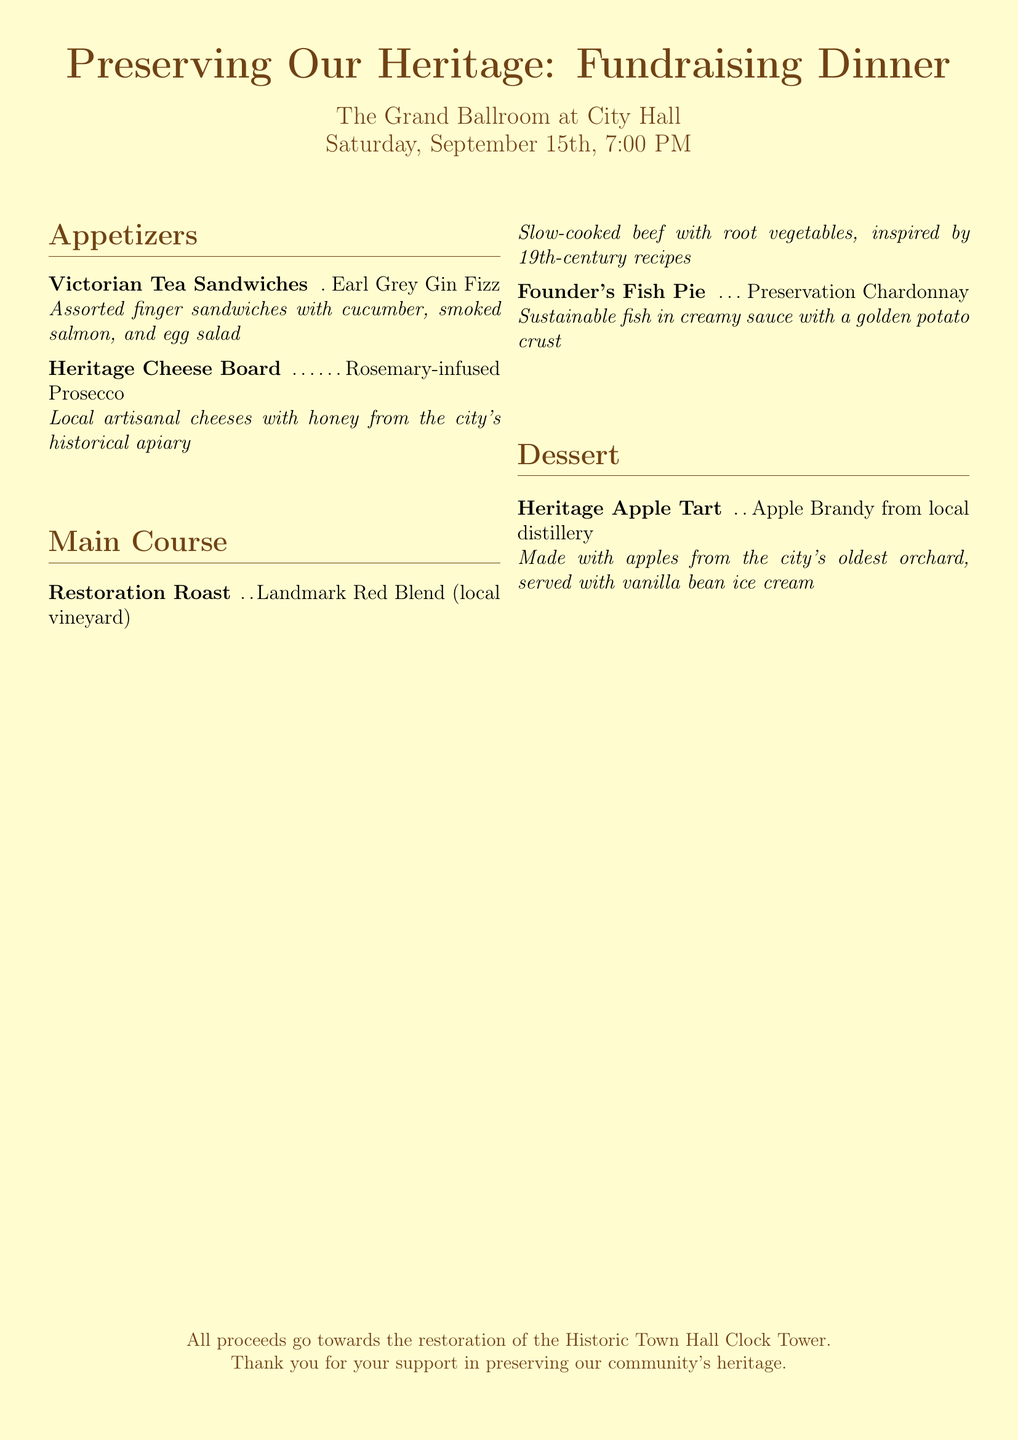What is the title of the event? The title of the event is prominently displayed at the top of the menu.
Answer: Preserving Our Heritage: Fundraising Dinner Where will the event take place? The location of the event is listed below the title of the menu.
Answer: The Grand Ballroom at City Hall What is the date of the event? The date of the event is provided in the introductory section of the menu.
Answer: Saturday, September 15th How many appetizers are listed in the menu? The appetizers section contains two menu items, indicating the total count.
Answer: 2 What drink is paired with the Restoration Roast? The pairing for the Restoration Roast is specified in the main course section.
Answer: Landmark Red Blend (local vineyard) What is the main ingredient in the Founder's Fish Pie? The main course describes the Founder's Fish Pie and its contents clearly.
Answer: Sustainable fish Which dessert features local apples? In the dessert section, the Heritage Apple Tart is explicitly mentioned to use local apples.
Answer: Heritage Apple Tart What type of cheese is included in the Heritage Cheese Board? The description indicates that the cheeses used are sourced locally.
Answer: Local artisanal cheeses What is the purpose of the event? The purpose is stated at the bottom of the menu describing where the proceeds will go.
Answer: Restoration of the Historic Town Hall Clock Tower 